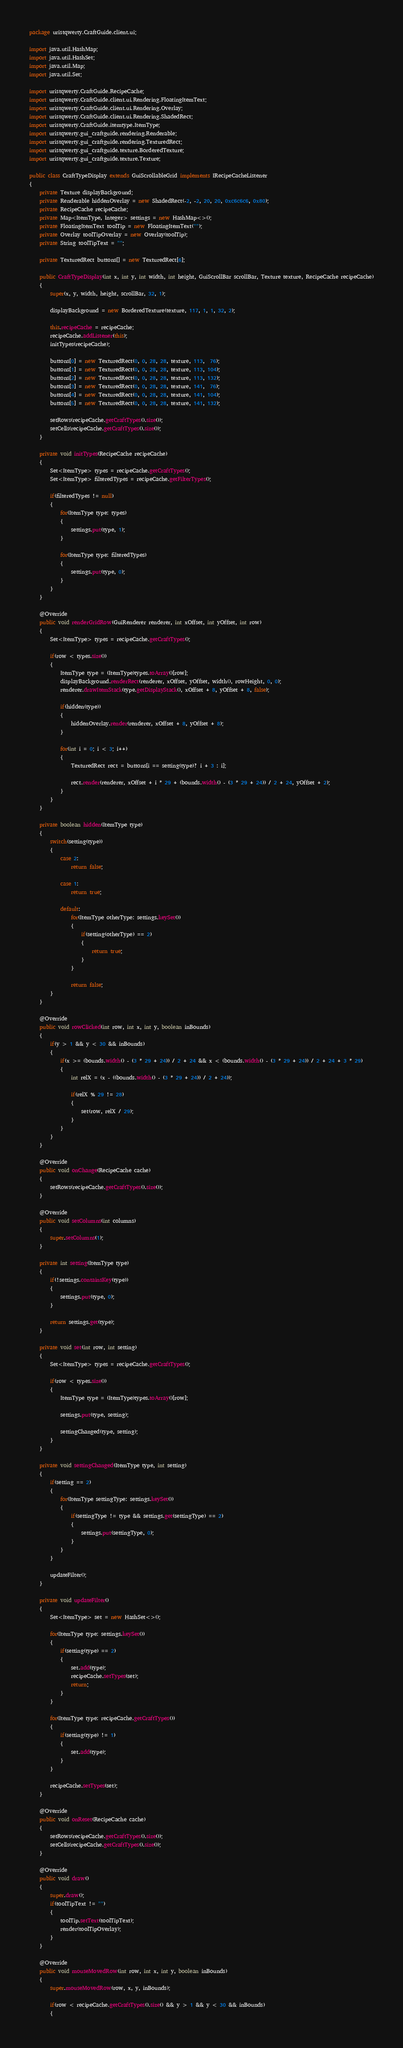<code> <loc_0><loc_0><loc_500><loc_500><_Java_>package uristqwerty.CraftGuide.client.ui;

import java.util.HashMap;
import java.util.HashSet;
import java.util.Map;
import java.util.Set;

import uristqwerty.CraftGuide.RecipeCache;
import uristqwerty.CraftGuide.client.ui.Rendering.FloatingItemText;
import uristqwerty.CraftGuide.client.ui.Rendering.Overlay;
import uristqwerty.CraftGuide.client.ui.Rendering.ShadedRect;
import uristqwerty.CraftGuide.itemtype.ItemType;
import uristqwerty.gui_craftguide.rendering.Renderable;
import uristqwerty.gui_craftguide.rendering.TexturedRect;
import uristqwerty.gui_craftguide.texture.BorderedTexture;
import uristqwerty.gui_craftguide.texture.Texture;

public class CraftTypeDisplay extends GuiScrollableGrid implements IRecipeCacheListener
{
	private Texture displayBackground;
	private Renderable hiddenOverlay = new ShadedRect(-2, -2, 20, 20, 0xc6c6c6, 0x80);
	private RecipeCache recipeCache;
	private Map<ItemType, Integer> settings = new HashMap<>();
	private FloatingItemText toolTip = new FloatingItemText("");
	private Overlay toolTipOverlay = new Overlay(toolTip);
	private String toolTipText = "";

	private TexturedRect buttons[] = new TexturedRect[6];

	public CraftTypeDisplay(int x, int y, int width, int height, GuiScrollBar scrollBar, Texture texture, RecipeCache recipeCache)
	{
		super(x, y, width, height, scrollBar, 32, 1);

		displayBackground = new BorderedTexture(texture, 117, 1, 1, 32, 2);

		this.recipeCache = recipeCache;
		recipeCache.addListener(this);
		initTypes(recipeCache);

		buttons[0] = new TexturedRect(0, 0, 28, 28, texture, 113,  76);
		buttons[1] = new TexturedRect(0, 0, 28, 28, texture, 113, 104);
		buttons[2] = new TexturedRect(0, 0, 28, 28, texture, 113, 132);
		buttons[3] = new TexturedRect(0, 0, 28, 28, texture, 141,  76);
		buttons[4] = new TexturedRect(0, 0, 28, 28, texture, 141, 104);
		buttons[5] = new TexturedRect(0, 0, 28, 28, texture, 141, 132);

		setRows(recipeCache.getCraftTypes().size());
		setCells(recipeCache.getCraftTypes().size());
	}

	private void initTypes(RecipeCache recipeCache)
	{
		Set<ItemType> types = recipeCache.getCraftTypes();
		Set<ItemType> filteredTypes = recipeCache.getFilterTypes();

		if(filteredTypes != null)
		{
			for(ItemType type: types)
			{
				settings.put(type, 1);
			}

			for(ItemType type: filteredTypes)
			{
				settings.put(type, 0);
			}
		}
	}

	@Override
	public void renderGridRow(GuiRenderer renderer, int xOffset, int yOffset, int row)
	{
		Set<ItemType> types = recipeCache.getCraftTypes();

		if(row < types.size())
		{
			ItemType type = (ItemType)types.toArray()[row];
			displayBackground.renderRect(renderer, xOffset, yOffset, width(), rowHeight, 0, 0);
			renderer.drawItemStack(type.getDisplayStack(), xOffset + 8, yOffset + 8, false);

			if(hidden(type))
			{
				hiddenOverlay.render(renderer, xOffset + 8, yOffset + 8);
			}

			for(int i = 0; i < 3; i++)
			{
				TexturedRect rect = buttons[i == setting(type)? i + 3 : i];

				rect.render(renderer, xOffset + i * 29 + (bounds.width() - (3 * 29 + 24)) / 2 + 24, yOffset + 2);
			}
		}
	}

	private boolean hidden(ItemType type)
	{
		switch(setting(type))
		{
			case 2:
				return false;

			case 1:
				return true;

			default:
				for(ItemType otherType: settings.keySet())
				{
					if(setting(otherType) == 2)
					{
						return true;
					}
				}

				return false;
		}
	}

	@Override
	public void rowClicked(int row, int x, int y, boolean inBounds)
	{
		if(y > 1 && y < 30 && inBounds)
		{
			if(x >= (bounds.width() - (3 * 29 + 24)) / 2 + 24 && x < (bounds.width() - (3 * 29 + 24)) / 2 + 24 + 3 * 29)
			{
				int relX = (x - ((bounds.width() - (3 * 29 + 24)) / 2 + 24));

				if(relX % 29 != 28)
				{
					set(row, relX / 29);
				}
			}
		}
	}

	@Override
	public void onChange(RecipeCache cache)
	{
		setRows(recipeCache.getCraftTypes().size());
	}

	@Override
	public void setColumns(int columns)
	{
		super.setColumns(1);
	}

	private int setting(ItemType type)
	{
		if(!settings.containsKey(type))
		{
			settings.put(type, 0);
		}

		return settings.get(type);
	}

	private void set(int row, int setting)
	{
		Set<ItemType> types = recipeCache.getCraftTypes();

		if(row < types.size())
		{
			ItemType type = (ItemType)types.toArray()[row];

			settings.put(type, setting);

			settingChanged(type, setting);
		}
	}

	private void settingChanged(ItemType type, int setting)
	{
		if(setting == 2)
		{
			for(ItemType settingType: settings.keySet())
			{
				if(settingType != type && settings.get(settingType) == 2)
				{
					settings.put(settingType, 0);
				}
			}
		}

		updateFilter();
	}

	private void updateFilter()
	{
		Set<ItemType> set = new HashSet<>();

		for(ItemType type: settings.keySet())
		{
			if(setting(type) == 2)
			{
				set.add(type);
				recipeCache.setTypes(set);
				return;
			}
		}

		for(ItemType type: recipeCache.getCraftTypes())
		{
			if(setting(type) != 1)
			{
				set.add(type);
			}
		}

		recipeCache.setTypes(set);
	}

	@Override
	public void onReset(RecipeCache cache)
	{
		setRows(recipeCache.getCraftTypes().size());
		setCells(recipeCache.getCraftTypes().size());
	}

	@Override
	public void draw()
	{
		super.draw();
		if(toolTipText != "")
		{
			toolTip.setText(toolTipText);
			render(toolTipOverlay);
		}
	}

	@Override
	public void mouseMovedRow(int row, int x, int y, boolean inBounds)
	{
		super.mouseMovedRow(row, x, y, inBounds);

		if(row < recipeCache.getCraftTypes().size() && y > 1 && y < 30 && inBounds)
		{</code> 